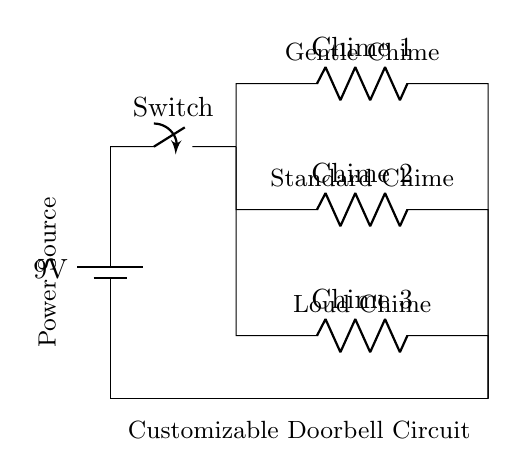What is the voltage of this circuit? The voltage of the circuit is 9 volts as indicated by the battery labeled with that value.
Answer: 9 volts What type of circuit is this? This is a parallel circuit because it has multiple branches (chime options) that connect to the same power source, allowing current to flow through more than one path simultaneously.
Answer: Parallel How many chime options are available? There are three chime options shown in the circuit diagram, as indicated by the three resistors labeled Chime 1, Chime 2, and Chime 3.
Answer: Three What is the function of the switch in the circuit? The switch functions as a control mechanism that can open or close the circuit, allowing the user to turn the doorbell on or off.
Answer: Control mechanism What happens if Chime 2 is chosen? If Chime 2 is chosen (the branch connected to it is closed), it will draw current from the 9-volt battery, creating the sound specific to Chime 2 while the other two chimes remain silent.
Answer: Draws current Which chime produces the loudest sound? The loudest sound is produced by Chime 3, which is typically labeled or understood as being louder than the others based on conventional naming.
Answer: Chime 3 